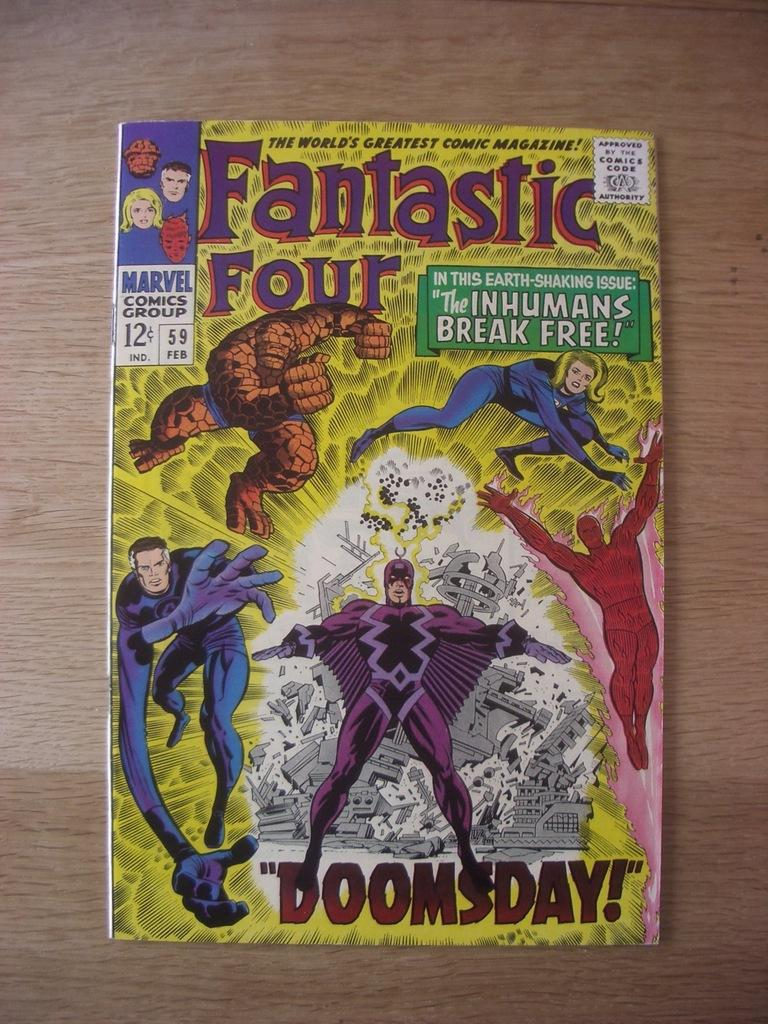<image>
Provide a brief description of the given image. A fantastic four comic book titles Doomsday with the Thing on it. 